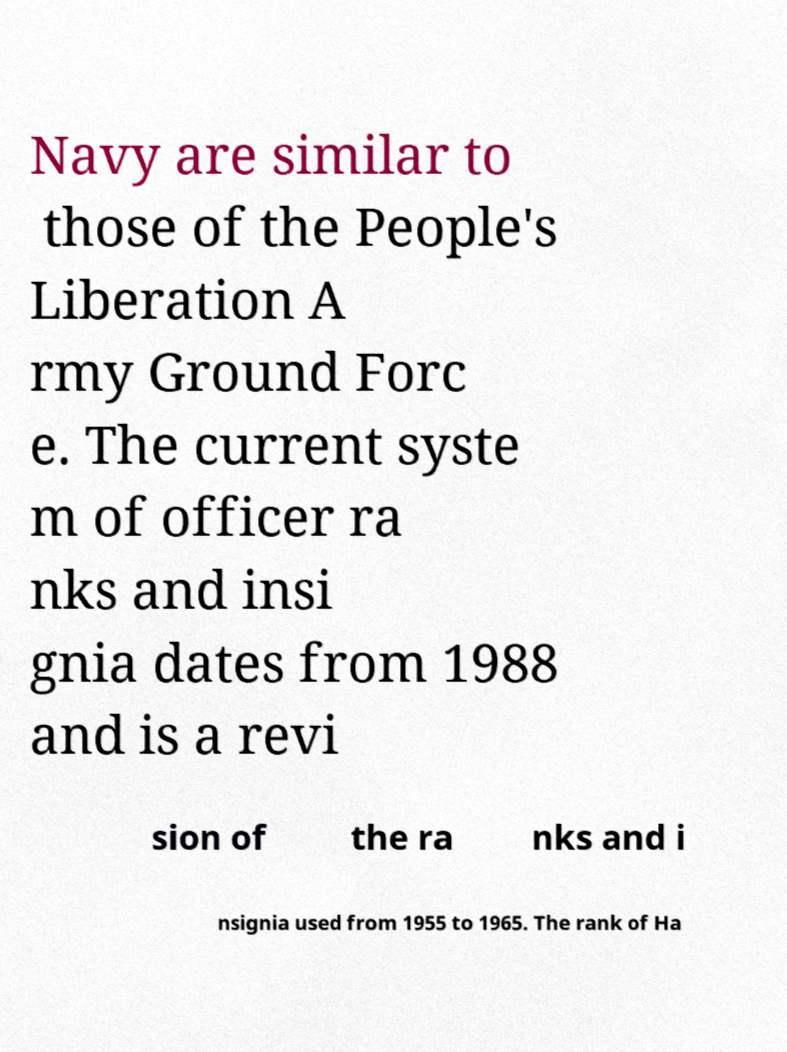Could you extract and type out the text from this image? Navy are similar to those of the People's Liberation A rmy Ground Forc e. The current syste m of officer ra nks and insi gnia dates from 1988 and is a revi sion of the ra nks and i nsignia used from 1955 to 1965. The rank of Ha 